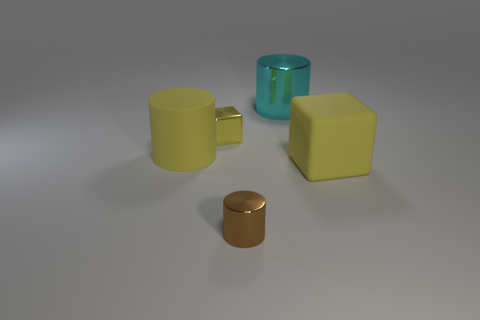Subtract all large rubber cylinders. How many cylinders are left? 2 Subtract all yellow cylinders. How many cylinders are left? 2 Add 3 big brown rubber cylinders. How many objects exist? 8 Subtract all red cylinders. How many cyan cubes are left? 0 Subtract all tiny green balls. Subtract all large yellow things. How many objects are left? 3 Add 1 yellow metal cubes. How many yellow metal cubes are left? 2 Add 3 large yellow things. How many large yellow things exist? 5 Subtract 0 purple spheres. How many objects are left? 5 Subtract all blocks. How many objects are left? 3 Subtract 1 cubes. How many cubes are left? 1 